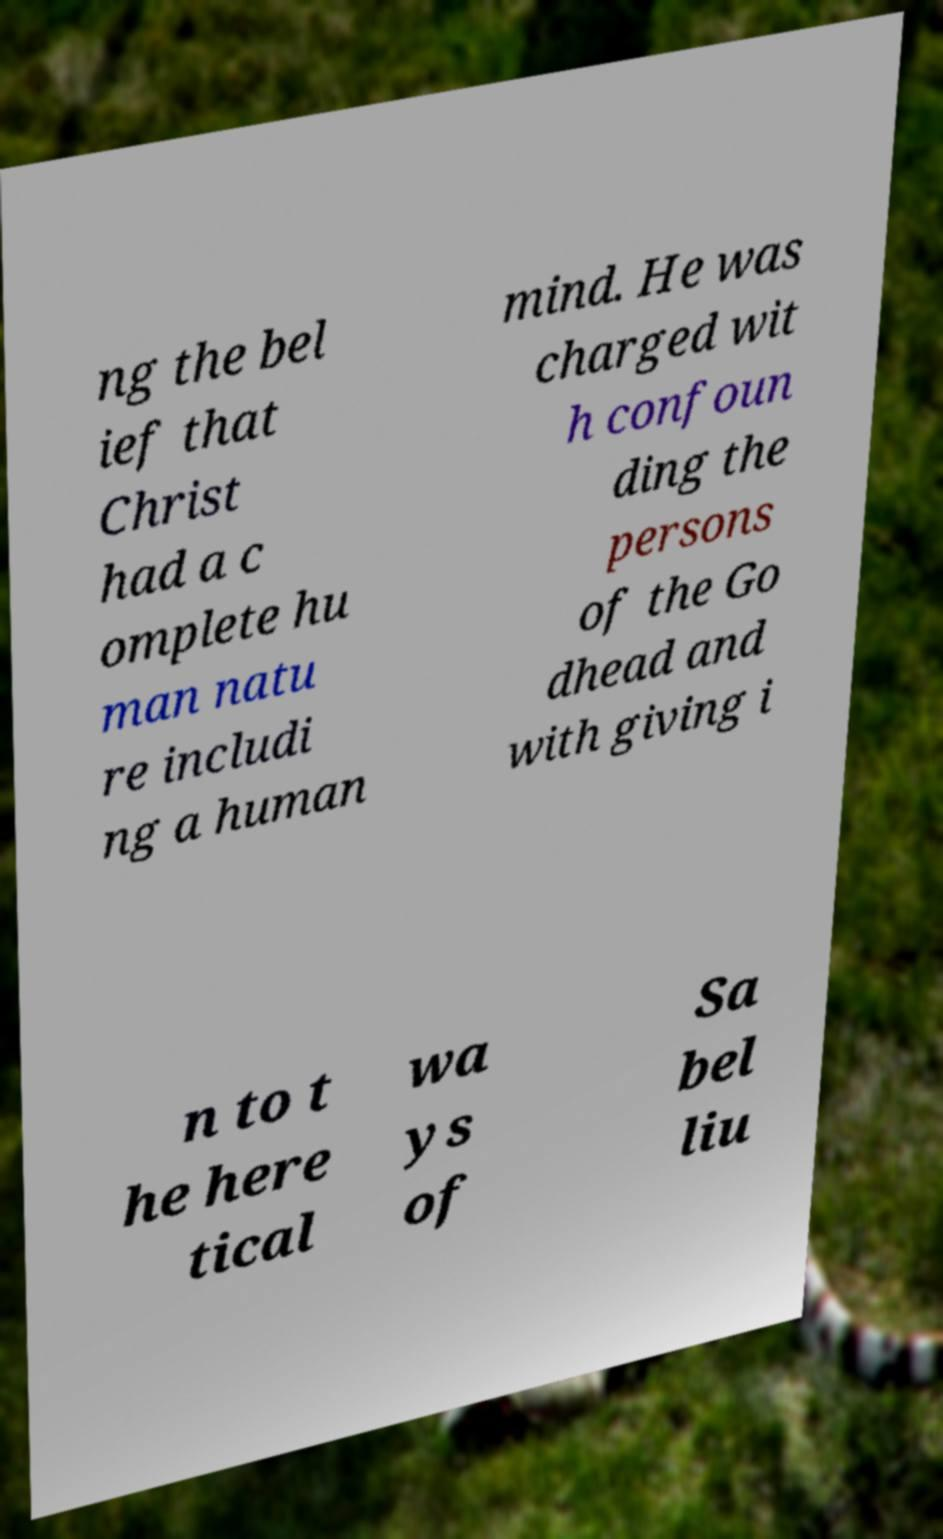What messages or text are displayed in this image? I need them in a readable, typed format. ng the bel ief that Christ had a c omplete hu man natu re includi ng a human mind. He was charged wit h confoun ding the persons of the Go dhead and with giving i n to t he here tical wa ys of Sa bel liu 